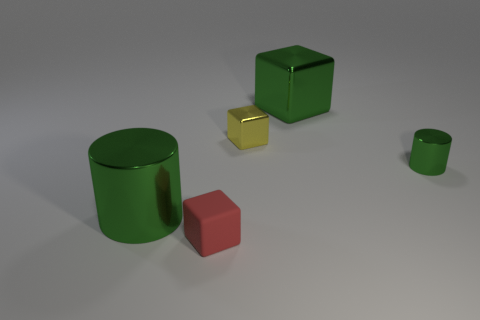Add 4 big green shiny blocks. How many objects exist? 9 Subtract all metallic blocks. How many blocks are left? 1 Subtract 2 cylinders. How many cylinders are left? 0 Subtract all yellow cylinders. How many yellow cubes are left? 1 Subtract all green cubes. How many cubes are left? 2 Subtract all cylinders. How many objects are left? 3 Subtract all purple cubes. Subtract all gray cylinders. How many cubes are left? 3 Subtract all tiny blue blocks. Subtract all green shiny things. How many objects are left? 2 Add 4 red blocks. How many red blocks are left? 5 Add 4 large green metallic things. How many large green metallic things exist? 6 